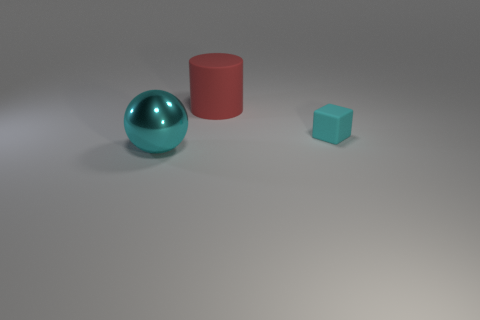Add 3 big blue metallic cubes. How many objects exist? 6 Subtract all cubes. How many objects are left? 2 Subtract all red cylinders. Subtract all large cyan objects. How many objects are left? 1 Add 3 large shiny balls. How many large shiny balls are left? 4 Add 3 cyan spheres. How many cyan spheres exist? 4 Subtract 0 red cubes. How many objects are left? 3 